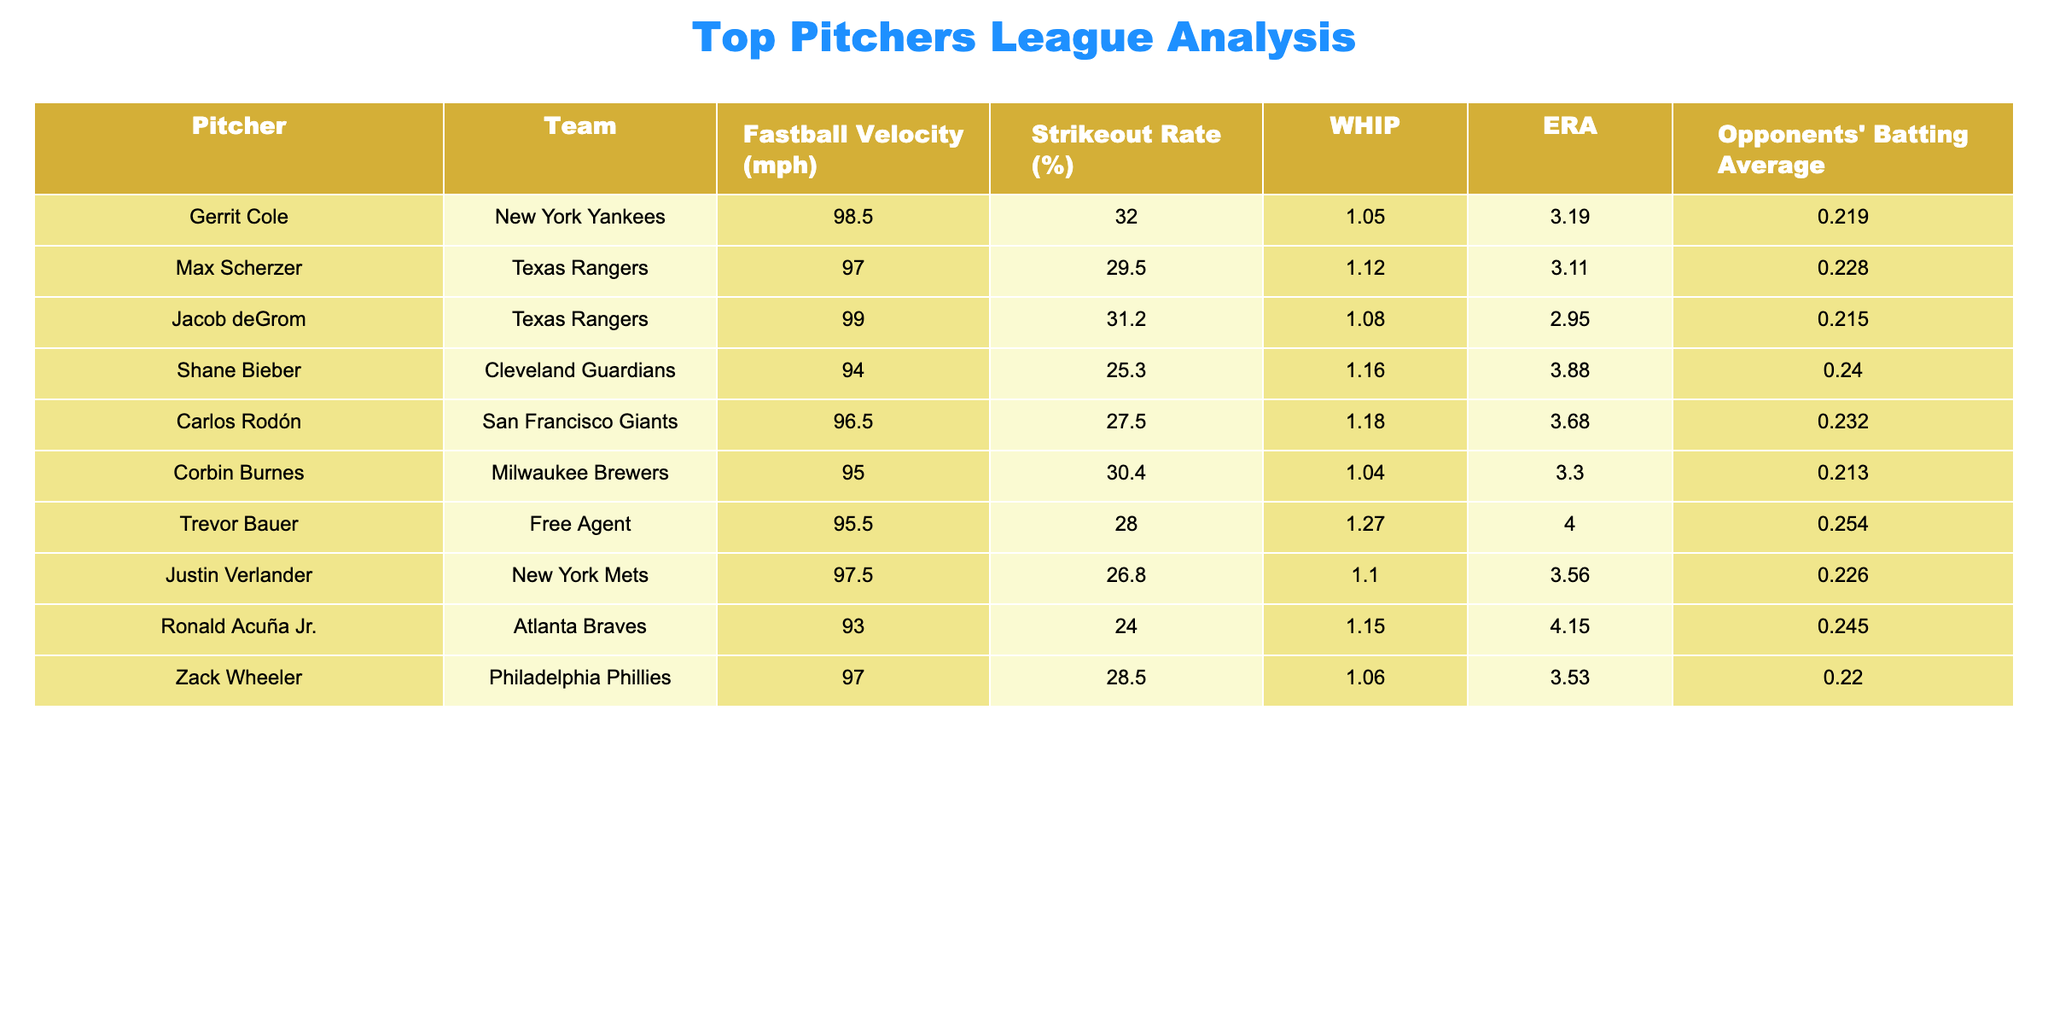What is the fastest fastball velocity recorded in the table? The fastest fastball velocity can be found by looking through the 'Fastball Velocity (mph)' column. The highest value is 99.0 mph, recorded by Jacob deGrom.
Answer: 99.0 mph Which pitcher has the highest strikeout rate? To find the highest strikeout rate, I will check the 'Strikeout Rate (%)' column. The maximum value is 32.0%, which belongs to Gerrit Cole.
Answer: 32.0% What is the average ERA of all the pitchers listed? First, I will sum the ERA values shown in the 'ERA' column: (3.19 + 3.11 + 2.95 + 3.88 + 3.68 + 3.30 + 4.00 + 3.56 + 4.15 + 3.53) = 33.25. There are 10 pitchers, so the average ERA = 33.25 / 10 = 3.325.
Answer: 3.325 Is Carlos Rodón's WHIP higher than Max Scherzer's WHIP? I will compare the 'WHIP' values for both pitchers. Carlos Rodón has a WHIP of 1.18, while Max Scherzer has a WHIP of 1.12. Since 1.18 is greater than 1.12, the statement is true.
Answer: Yes What pitcher has the lowest opponents' batting average? I will look through the 'Opponents' Batting Average' column to find the lowest value. The lowest value is .213, associated with Corbin Burnes.
Answer: .213 Are there more pitchers with a strikeout rate above 30% than below? I will count the number of pitchers in each category by checking the 'Strikeout Rate (%)' column. There are 5 pitchers (Cole, deGrom, Burnes, Scherzer, and Wheeler) with rates above 30%, and there are 5 pitchers (Bieber, Rodón, Bauer, Verlander, and Acuña) below. Since both counts are equal, the statement is false.
Answer: No What is the difference in fastball velocity between the fastest and slowest pitcher? The fastest pitcher is Jacob deGrom with a velocity of 99.0 mph, and the slowest is Ronald Acuña Jr. with a velocity of 93.0 mph. The difference = 99.0 - 93.0 = 6.0 mph.
Answer: 6.0 mph Which team has the pitcher with the highest ERA? I will compare the ERA values to determine which team has the highest value. Trevor Bauer has the highest ERA at 4.00, and he is a free agent. Thus, the answer is not associated with a team.
Answer: Free Agent What is the total strikeout rate of the pitchers from the Texas Rangers? Only two pitchers are from the Texas Rangers: Max Scherzer (29.5%) and Jacob deGrom (31.2%). I will sum these rates: 29.5 + 31.2 = 60.7%.
Answer: 60.7% 